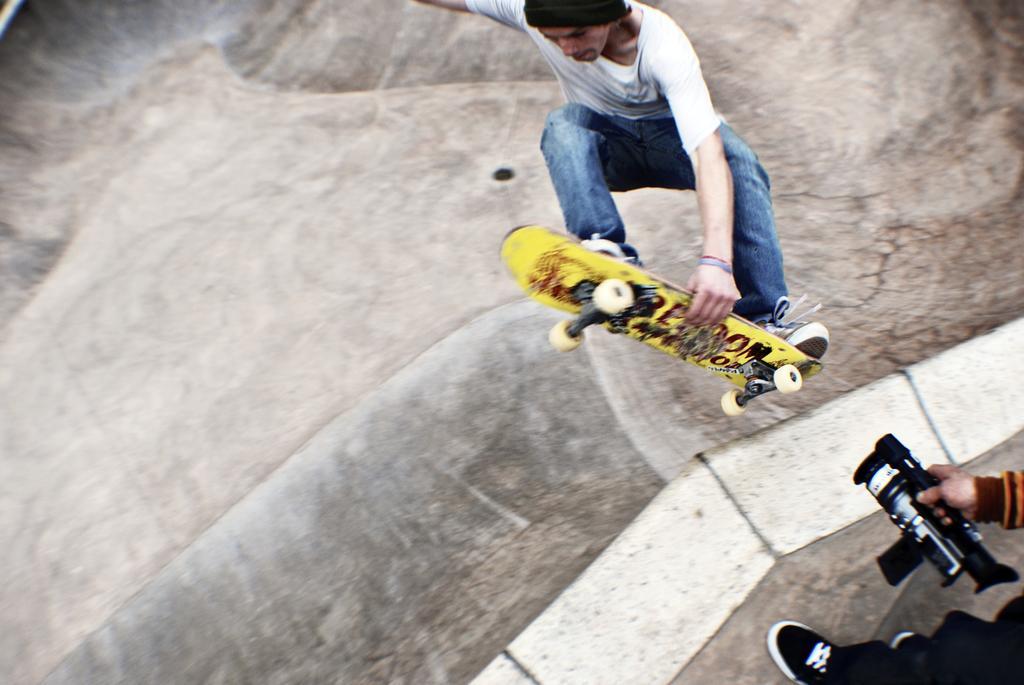In one or two sentences, can you explain what this image depicts? In this image we can see a man jumping with skating board. On the right we can see a person holding a camera. At the bottom there is a road. 